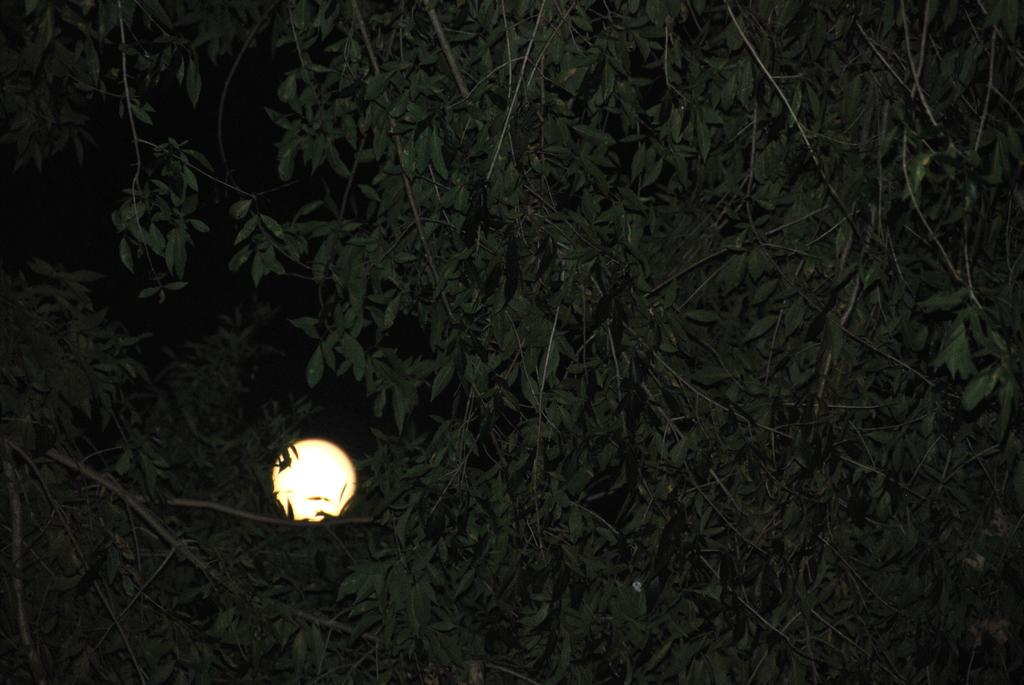What type of vegetation can be seen in the image? There are trees in the image. What celestial body is visible in the background of the image? The moon is visible in the background of the image. How would you describe the lighting in the image? The background appears dark in the image. How does the team feel about their recent loss in the image? There is no mention of a team or any loss in the image, so it is not possible to answer this question. 